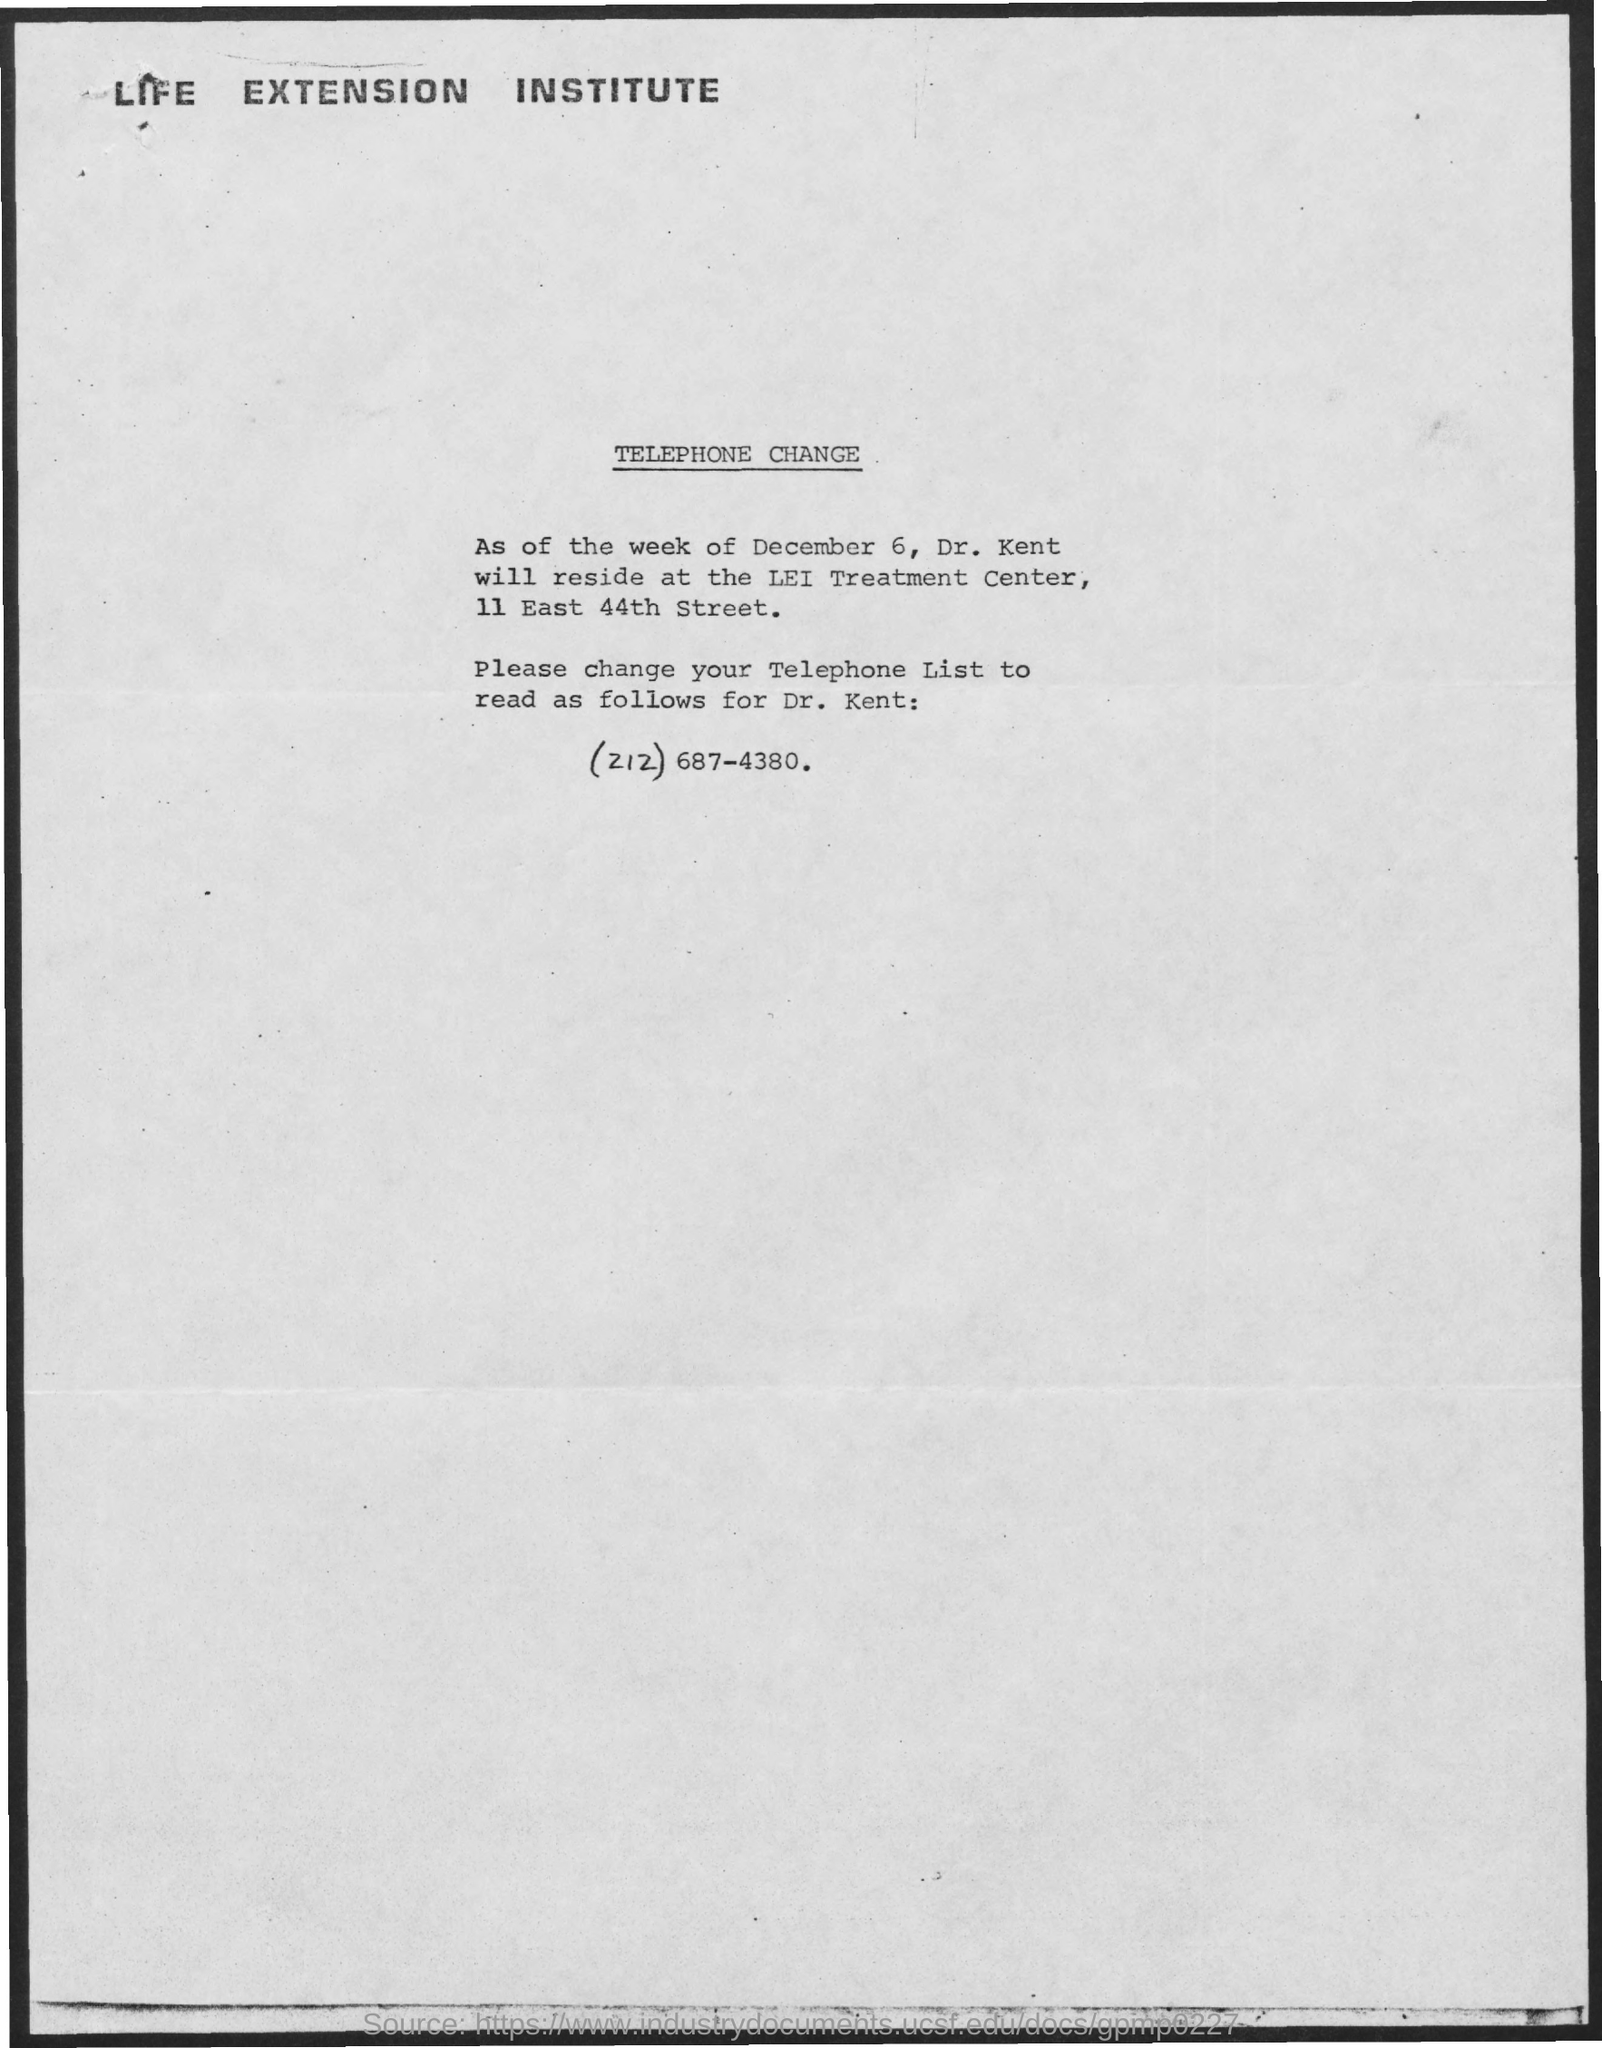What is the first title in the document?
Provide a short and direct response. Life Extension Institute. What is the second title in the document?
Your answer should be very brief. TELEPHONE CHANGE. What is the telephone number?
Offer a terse response. (212) 687-4380. 